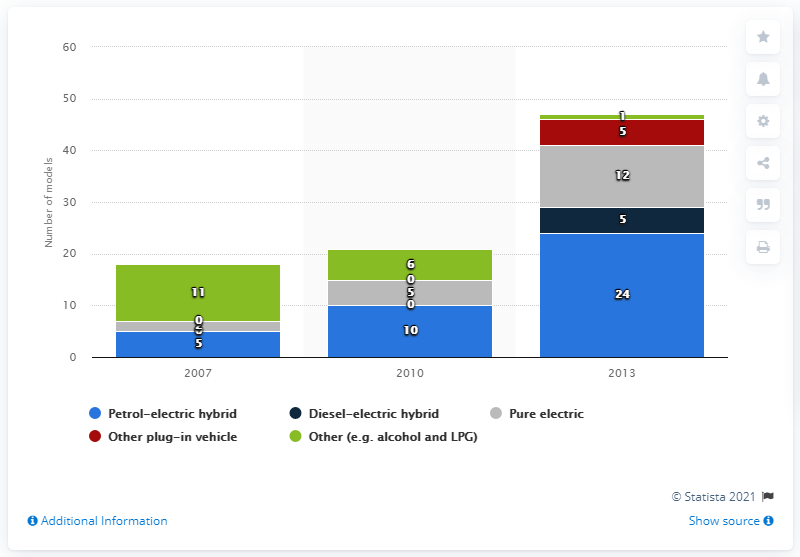Highlight a few significant elements in this photo. In the year 2007, a significant number of alternative fuel vehicles were available for use in the United Kingdom. In 2013, there were 12 pure electric vehicles available in the UK. 